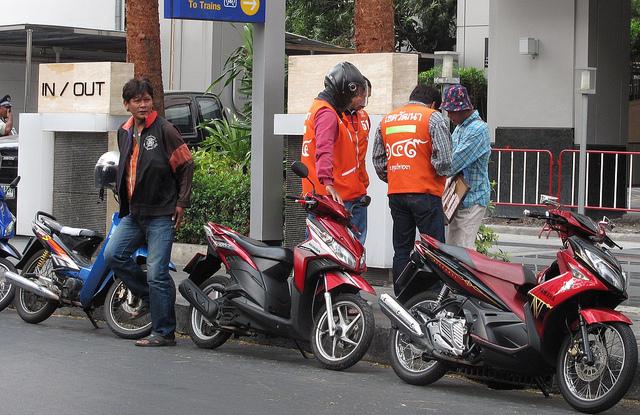Which person is not on the sidewalk?
Answer briefly. Person on left. What is the person wearing on his head?
Give a very brief answer. Helmet. Where is the bike parked?
Answer briefly. Street. Who is the motorcycle driver dressed as?
Concise answer only. Delivery boy. What is the man looking at?
Quick response, please. Road. Is everyone wearing pants?
Short answer required. Yes. What is the color of the garbage can?
Be succinct. White. Is this a current photograph?
Be succinct. Yes. How many cars are in this picture?
Give a very brief answer. 0. Are all of the men standing?
Short answer required. Yes. 